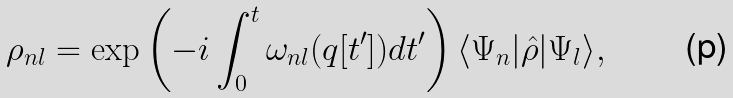<formula> <loc_0><loc_0><loc_500><loc_500>\rho _ { n l } = \exp \left ( - i \int _ { 0 } ^ { t } \omega _ { n l } ( q [ t ^ { \prime } ] ) d t ^ { \prime } \right ) \langle \Psi _ { n } | \hat { \rho } | \Psi _ { l } \rangle ,</formula> 